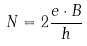Convert formula to latex. <formula><loc_0><loc_0><loc_500><loc_500>N = 2 \frac { e \cdot B } { h }</formula> 